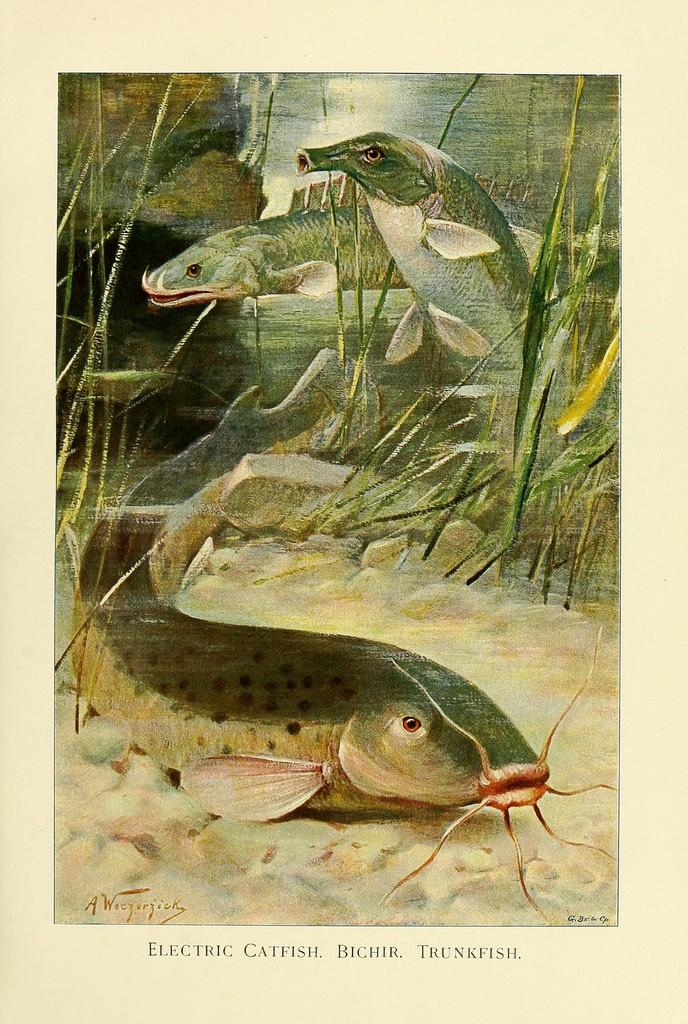What is the main subject of the image? There is a painting in the image. What is depicted in the painting? The painting depicts fishes and grass plants. What else can be seen in the background of the image? There are rocks visible behind the painting. Can you tell me how many jellyfish are swimming in the painting? There are no jellyfish depicted in the painting; it features fishes and grass plants. 